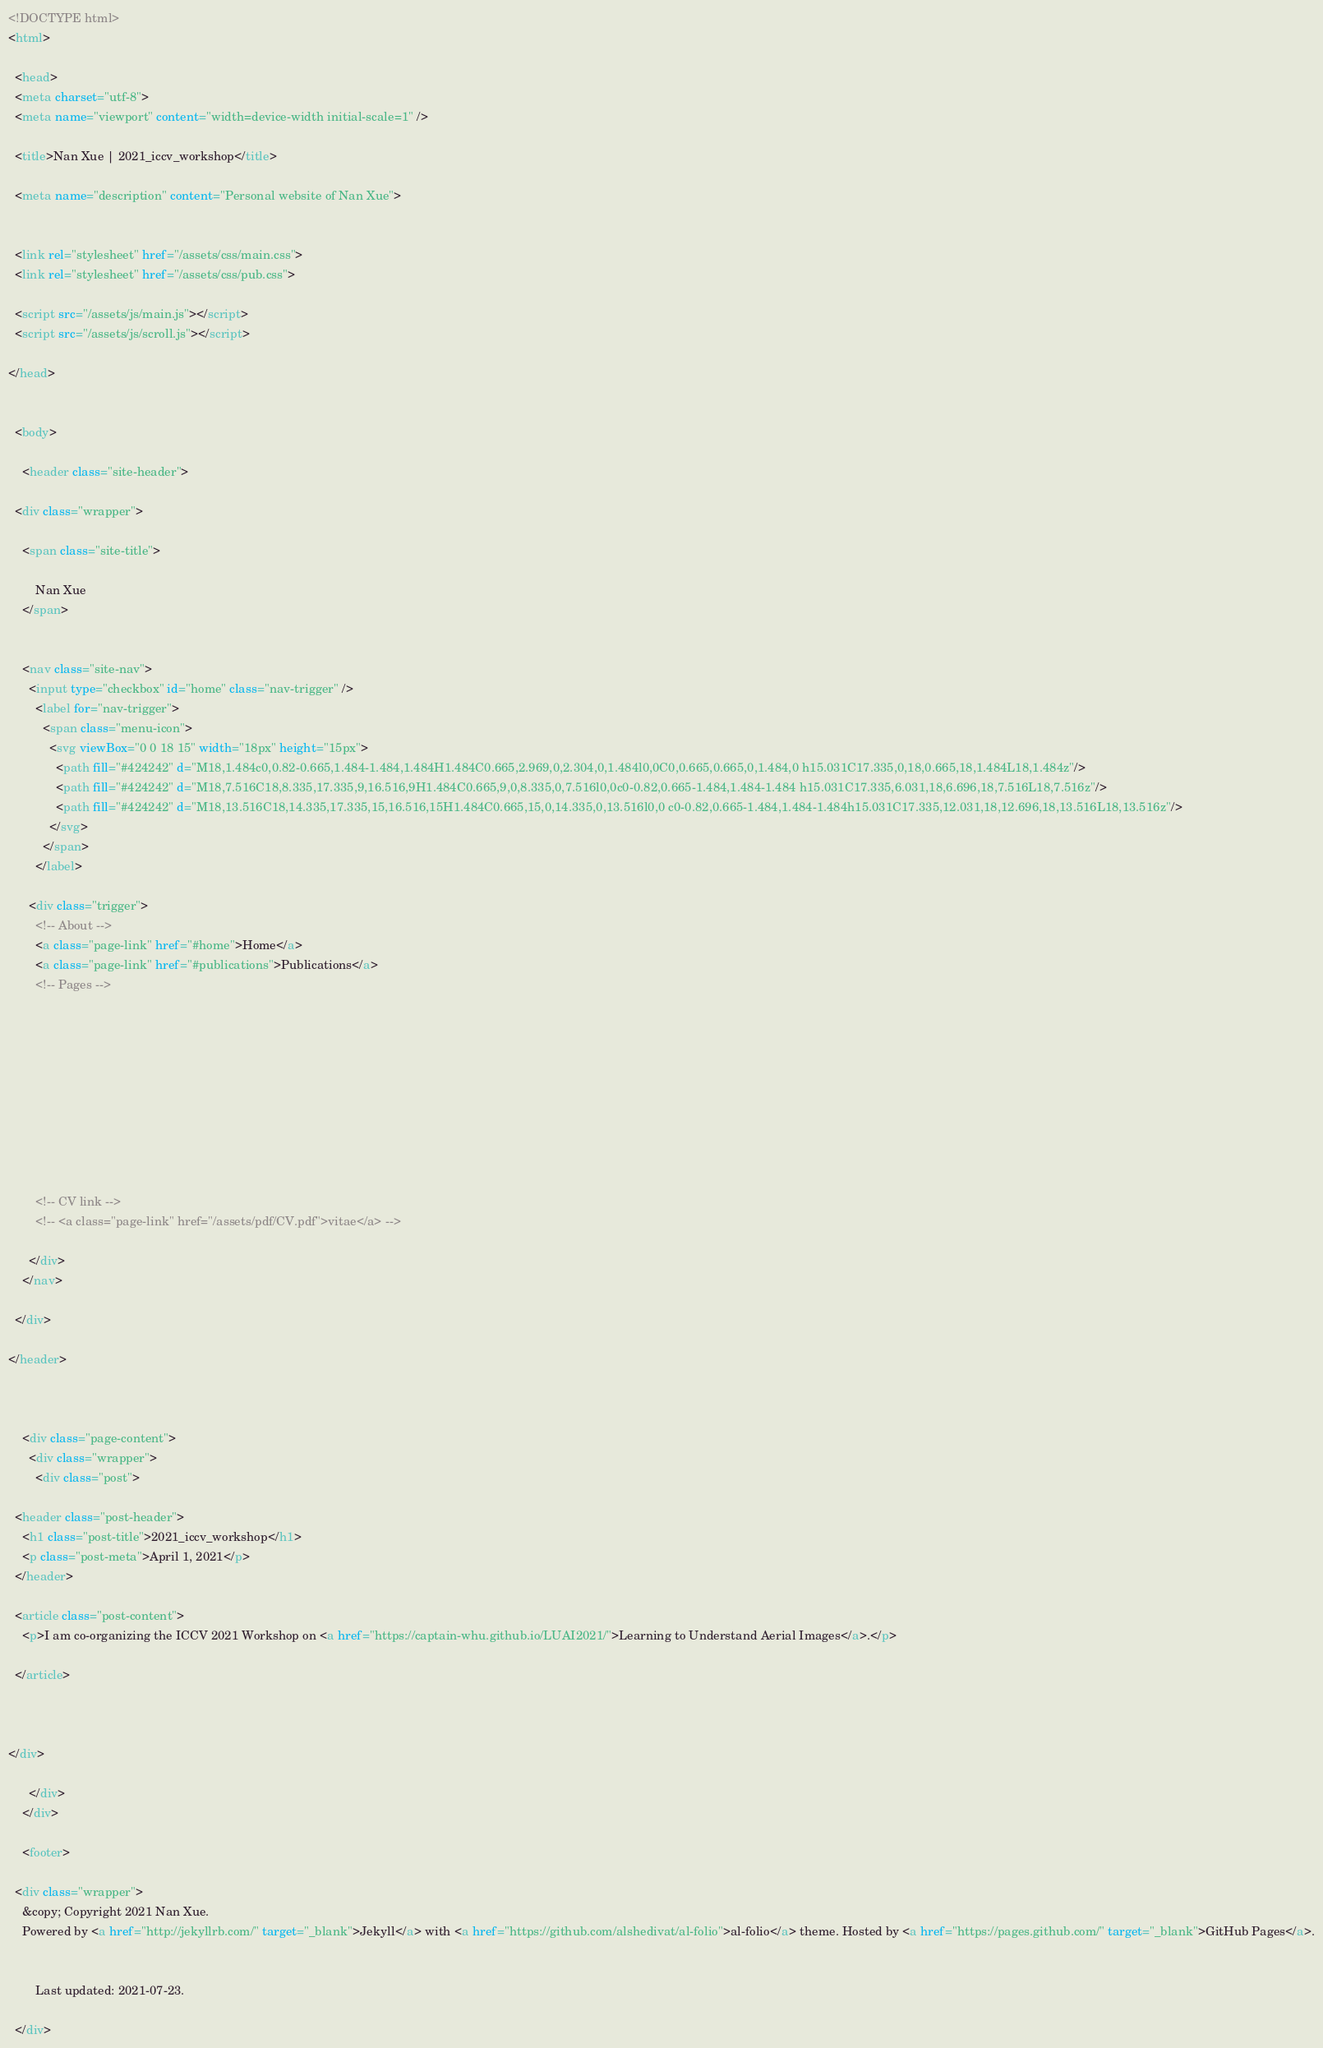Convert code to text. <code><loc_0><loc_0><loc_500><loc_500><_HTML_><!DOCTYPE html>
<html>

  <head>
  <meta charset="utf-8">
  <meta name="viewport" content="width=device-width initial-scale=1" />
  
  <title>Nan Xue | 2021_iccv_workshop</title>

  <meta name="description" content="Personal website of Nan Xue">


  <link rel="stylesheet" href="/assets/css/main.css">
  <link rel="stylesheet" href="/assets/css/pub.css">

  <script src="/assets/js/main.js"></script>
  <script src="/assets/js/scroll.js"></script>

</head>


  <body>

    <header class="site-header">

  <div class="wrapper">
  
    <span class="site-title">
        
        Nan Xue
    </span>
    

    <nav class="site-nav">
      <input type="checkbox" id="home" class="nav-trigger" />
        <label for="nav-trigger">
          <span class="menu-icon">
            <svg viewBox="0 0 18 15" width="18px" height="15px">
              <path fill="#424242" d="M18,1.484c0,0.82-0.665,1.484-1.484,1.484H1.484C0.665,2.969,0,2.304,0,1.484l0,0C0,0.665,0.665,0,1.484,0 h15.031C17.335,0,18,0.665,18,1.484L18,1.484z"/>
              <path fill="#424242" d="M18,7.516C18,8.335,17.335,9,16.516,9H1.484C0.665,9,0,8.335,0,7.516l0,0c0-0.82,0.665-1.484,1.484-1.484 h15.031C17.335,6.031,18,6.696,18,7.516L18,7.516z"/>
              <path fill="#424242" d="M18,13.516C18,14.335,17.335,15,16.516,15H1.484C0.665,15,0,14.335,0,13.516l0,0 c0-0.82,0.665-1.484,1.484-1.484h15.031C17.335,12.031,18,12.696,18,13.516L18,13.516z"/>
            </svg>
          </span>
        </label>

      <div class="trigger">
        <!-- About -->
        <a class="page-link" href="#home">Home</a>
        <a class="page-link" href="#publications">Publications</a>
        <!-- Pages -->
        
          
        
          
        
          
        
          
        

        <!-- CV link -->
        <!-- <a class="page-link" href="/assets/pdf/CV.pdf">vitae</a> -->

      </div>
    </nav>

  </div>

</header>



    <div class="page-content">
      <div class="wrapper">
        <div class="post">

  <header class="post-header">
    <h1 class="post-title">2021_iccv_workshop</h1>
    <p class="post-meta">April 1, 2021</p>
  </header>

  <article class="post-content">
    <p>I am co-organizing the ICCV 2021 Workshop on <a href="https://captain-whu.github.io/LUAI2021/">Learning to Understand Aerial Images</a>.</p>

  </article>

  

</div>

      </div>
    </div>

    <footer>

  <div class="wrapper">
    &copy; Copyright 2021 Nan Xue.
    Powered by <a href="http://jekyllrb.com/" target="_blank">Jekyll</a> with <a href="https://github.com/alshedivat/al-folio">al-folio</a> theme. Hosted by <a href="https://pages.github.com/" target="_blank">GitHub Pages</a>.

    
        Last updated: 2021-07-23.
    
  </div></code> 